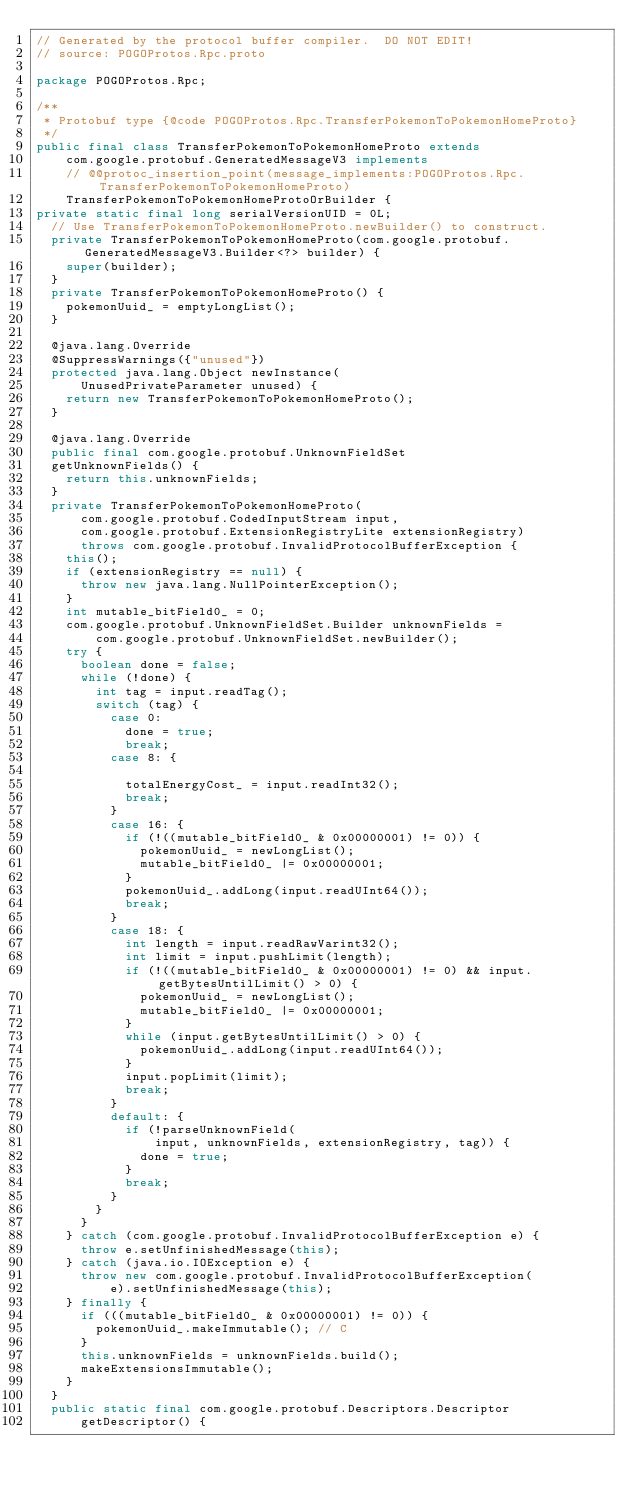Convert code to text. <code><loc_0><loc_0><loc_500><loc_500><_Java_>// Generated by the protocol buffer compiler.  DO NOT EDIT!
// source: POGOProtos.Rpc.proto

package POGOProtos.Rpc;

/**
 * Protobuf type {@code POGOProtos.Rpc.TransferPokemonToPokemonHomeProto}
 */
public final class TransferPokemonToPokemonHomeProto extends
    com.google.protobuf.GeneratedMessageV3 implements
    // @@protoc_insertion_point(message_implements:POGOProtos.Rpc.TransferPokemonToPokemonHomeProto)
    TransferPokemonToPokemonHomeProtoOrBuilder {
private static final long serialVersionUID = 0L;
  // Use TransferPokemonToPokemonHomeProto.newBuilder() to construct.
  private TransferPokemonToPokemonHomeProto(com.google.protobuf.GeneratedMessageV3.Builder<?> builder) {
    super(builder);
  }
  private TransferPokemonToPokemonHomeProto() {
    pokemonUuid_ = emptyLongList();
  }

  @java.lang.Override
  @SuppressWarnings({"unused"})
  protected java.lang.Object newInstance(
      UnusedPrivateParameter unused) {
    return new TransferPokemonToPokemonHomeProto();
  }

  @java.lang.Override
  public final com.google.protobuf.UnknownFieldSet
  getUnknownFields() {
    return this.unknownFields;
  }
  private TransferPokemonToPokemonHomeProto(
      com.google.protobuf.CodedInputStream input,
      com.google.protobuf.ExtensionRegistryLite extensionRegistry)
      throws com.google.protobuf.InvalidProtocolBufferException {
    this();
    if (extensionRegistry == null) {
      throw new java.lang.NullPointerException();
    }
    int mutable_bitField0_ = 0;
    com.google.protobuf.UnknownFieldSet.Builder unknownFields =
        com.google.protobuf.UnknownFieldSet.newBuilder();
    try {
      boolean done = false;
      while (!done) {
        int tag = input.readTag();
        switch (tag) {
          case 0:
            done = true;
            break;
          case 8: {

            totalEnergyCost_ = input.readInt32();
            break;
          }
          case 16: {
            if (!((mutable_bitField0_ & 0x00000001) != 0)) {
              pokemonUuid_ = newLongList();
              mutable_bitField0_ |= 0x00000001;
            }
            pokemonUuid_.addLong(input.readUInt64());
            break;
          }
          case 18: {
            int length = input.readRawVarint32();
            int limit = input.pushLimit(length);
            if (!((mutable_bitField0_ & 0x00000001) != 0) && input.getBytesUntilLimit() > 0) {
              pokemonUuid_ = newLongList();
              mutable_bitField0_ |= 0x00000001;
            }
            while (input.getBytesUntilLimit() > 0) {
              pokemonUuid_.addLong(input.readUInt64());
            }
            input.popLimit(limit);
            break;
          }
          default: {
            if (!parseUnknownField(
                input, unknownFields, extensionRegistry, tag)) {
              done = true;
            }
            break;
          }
        }
      }
    } catch (com.google.protobuf.InvalidProtocolBufferException e) {
      throw e.setUnfinishedMessage(this);
    } catch (java.io.IOException e) {
      throw new com.google.protobuf.InvalidProtocolBufferException(
          e).setUnfinishedMessage(this);
    } finally {
      if (((mutable_bitField0_ & 0x00000001) != 0)) {
        pokemonUuid_.makeImmutable(); // C
      }
      this.unknownFields = unknownFields.build();
      makeExtensionsImmutable();
    }
  }
  public static final com.google.protobuf.Descriptors.Descriptor
      getDescriptor() {</code> 